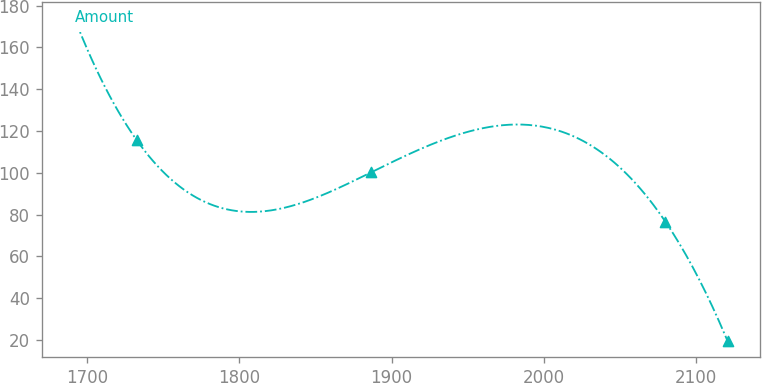Convert chart to OTSL. <chart><loc_0><loc_0><loc_500><loc_500><line_chart><ecel><fcel>Amount<nl><fcel>1691.57<fcel>173.94<nl><fcel>1732.47<fcel>115.6<nl><fcel>1886.34<fcel>100.14<nl><fcel>2079.95<fcel>76.61<nl><fcel>2120.85<fcel>19.37<nl></chart> 